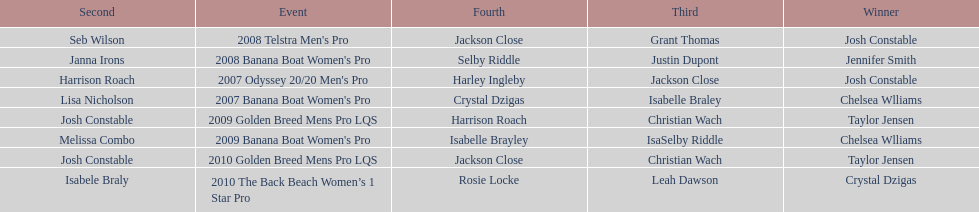What is the total number of times chelsea williams was the winner between 2007 and 2010? 2. 